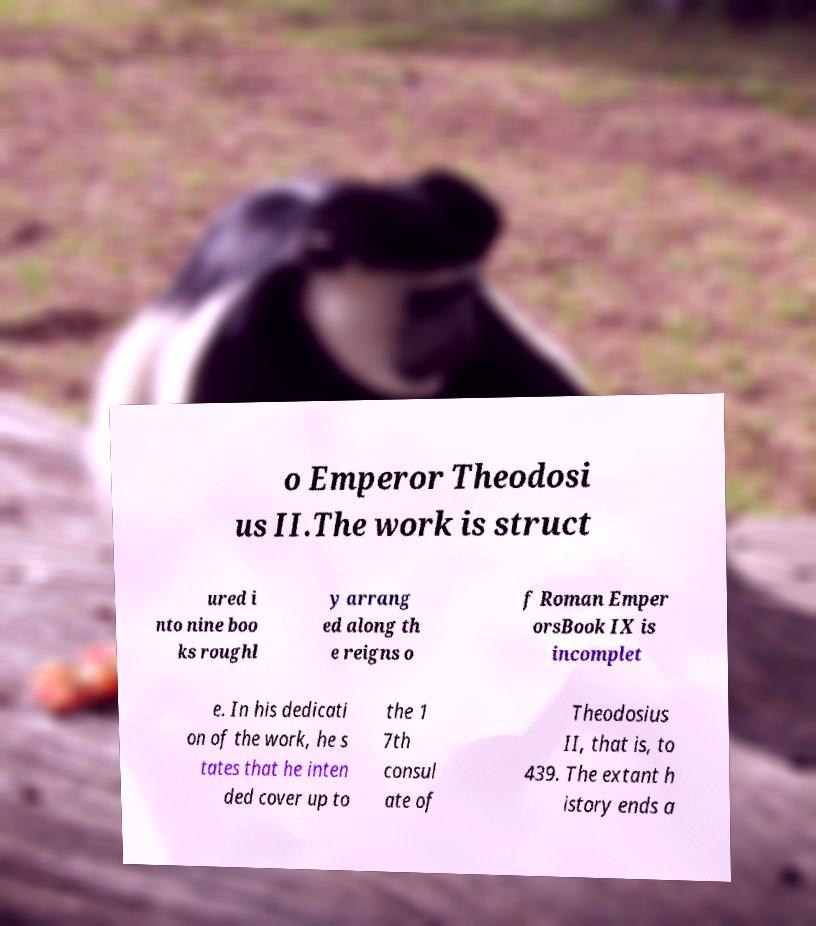There's text embedded in this image that I need extracted. Can you transcribe it verbatim? o Emperor Theodosi us II.The work is struct ured i nto nine boo ks roughl y arrang ed along th e reigns o f Roman Emper orsBook IX is incomplet e. In his dedicati on of the work, he s tates that he inten ded cover up to the 1 7th consul ate of Theodosius II, that is, to 439. The extant h istory ends a 